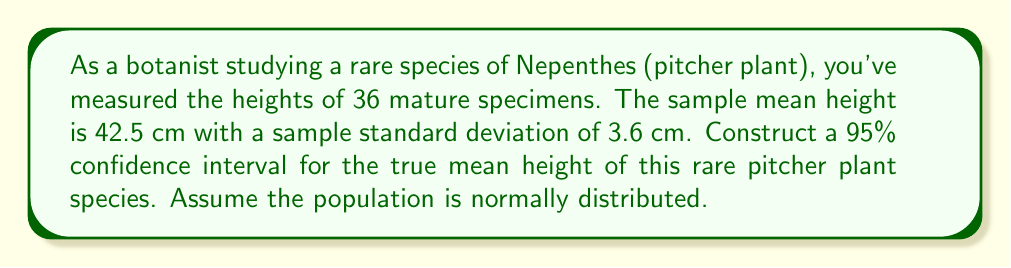Can you solve this math problem? Let's approach this step-by-step:

1) We're dealing with a confidence interval for a population mean with unknown population standard deviation. We'll use the t-distribution.

2) Given information:
   - Sample size: $n = 36$
   - Sample mean: $\bar{x} = 42.5$ cm
   - Sample standard deviation: $s = 3.6$ cm
   - Confidence level: 95%

3) The formula for the confidence interval is:

   $$ \bar{x} \pm t_{\alpha/2} \cdot \frac{s}{\sqrt{n}} $$

   where $t_{\alpha/2}$ is the t-value with degrees of freedom $df = n - 1 = 35$ and $\alpha/2 = 0.025$ (since it's a 95% confidence interval).

4) Find $t_{\alpha/2}$:
   For $df = 35$ and $\alpha/2 = 0.025$, $t_{\alpha/2} = 2.030$ (from t-distribution table)

5) Calculate the margin of error:

   $$ \text{Margin of Error} = t_{\alpha/2} \cdot \frac{s}{\sqrt{n}} = 2.030 \cdot \frac{3.6}{\sqrt{36}} = 1.22 $$

6) Calculate the confidence interval:

   Lower bound: $42.5 - 1.22 = 41.28$ cm
   Upper bound: $42.5 + 1.22 = 43.72$ cm

Therefore, we can be 95% confident that the true mean height of this rare pitcher plant species is between 41.28 cm and 43.72 cm.
Answer: (41.28 cm, 43.72 cm) 